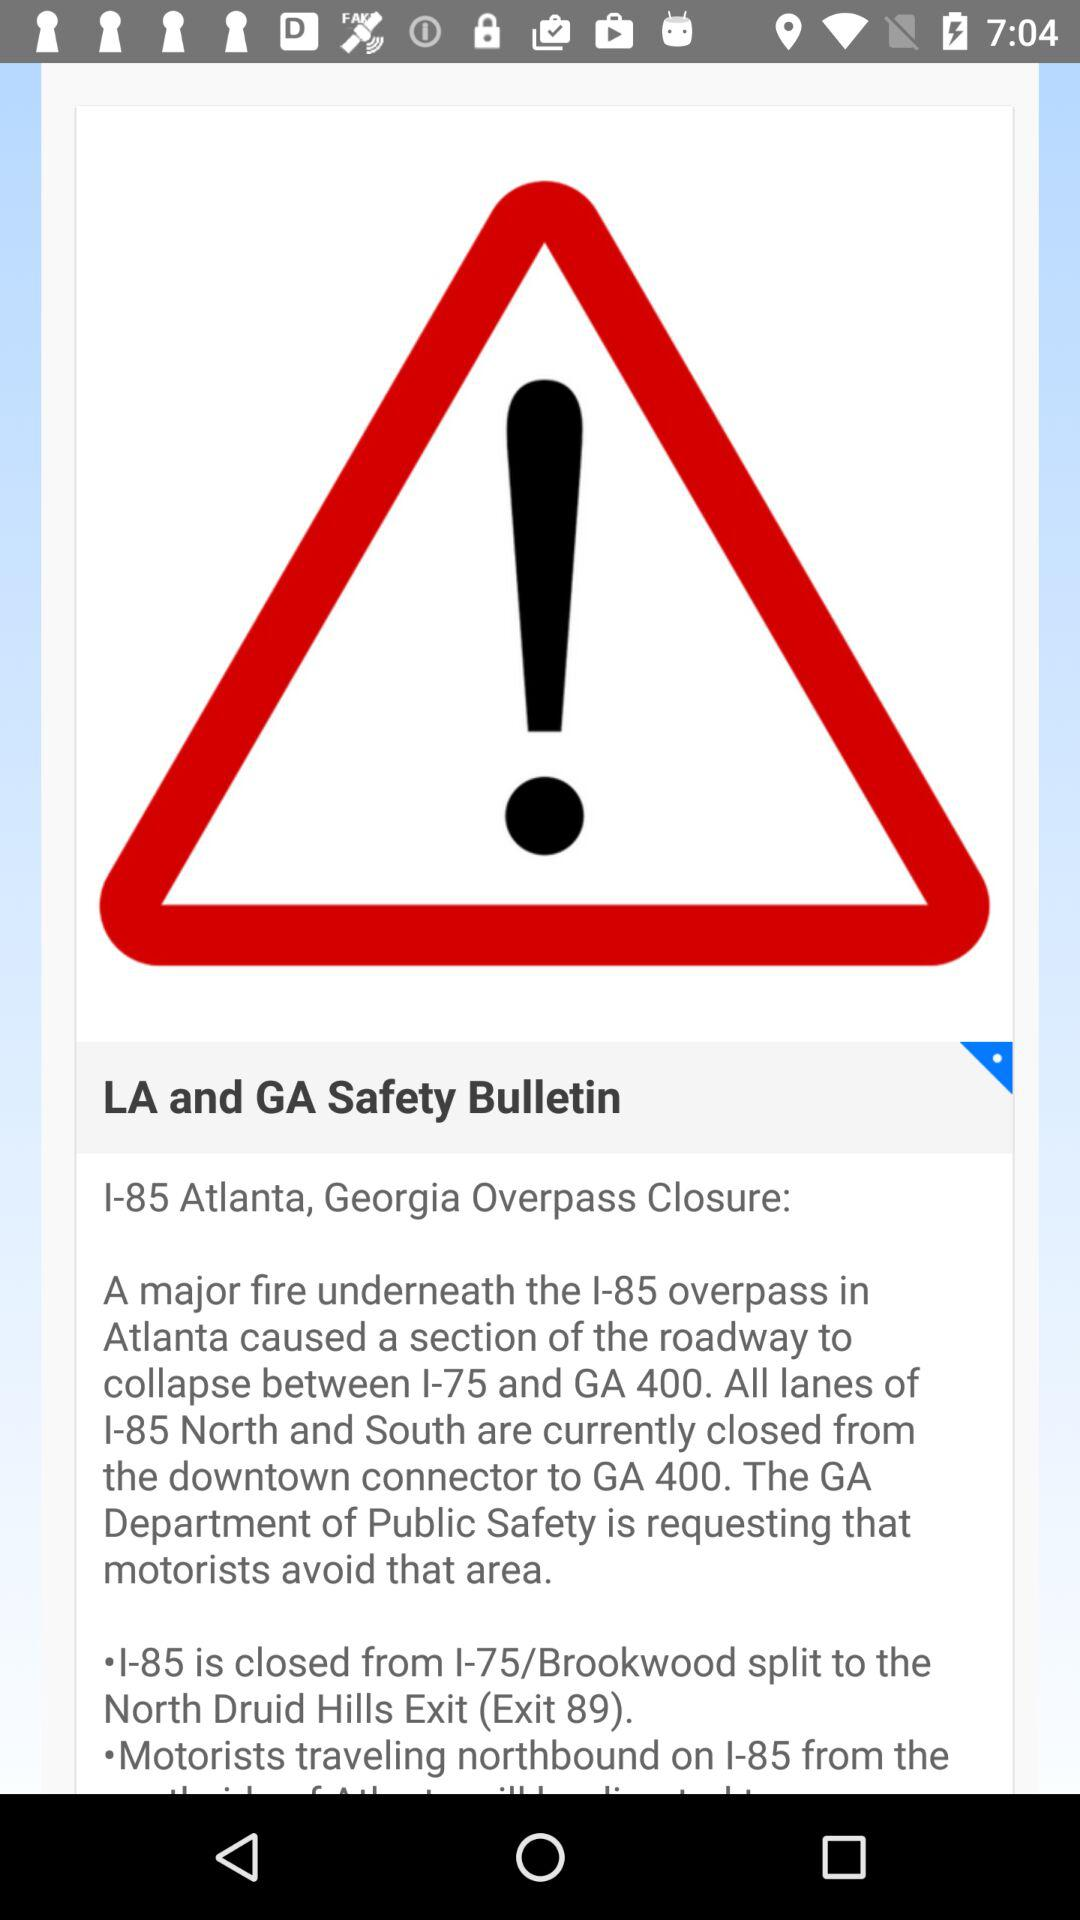How many exits are mentioned in the text?
Answer the question using a single word or phrase. 2 